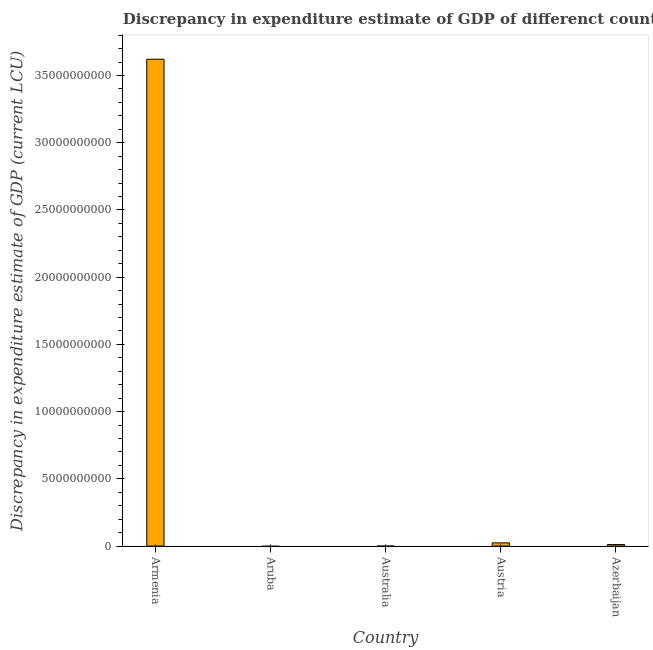Does the graph contain grids?
Provide a short and direct response. No. What is the title of the graph?
Offer a very short reply. Discrepancy in expenditure estimate of GDP of differenct countries in 1998. What is the label or title of the Y-axis?
Your answer should be very brief. Discrepancy in expenditure estimate of GDP (current LCU). What is the discrepancy in expenditure estimate of gdp in Armenia?
Your answer should be very brief. 3.62e+1. Across all countries, what is the maximum discrepancy in expenditure estimate of gdp?
Your response must be concise. 3.62e+1. Across all countries, what is the minimum discrepancy in expenditure estimate of gdp?
Provide a short and direct response. 0. In which country was the discrepancy in expenditure estimate of gdp maximum?
Provide a short and direct response. Armenia. What is the sum of the discrepancy in expenditure estimate of gdp?
Your answer should be compact. 3.66e+1. What is the difference between the discrepancy in expenditure estimate of gdp in Austria and Azerbaijan?
Make the answer very short. 1.25e+08. What is the average discrepancy in expenditure estimate of gdp per country?
Your answer should be compact. 7.31e+09. What is the median discrepancy in expenditure estimate of gdp?
Keep it short and to the point. 1.14e+08. What is the ratio of the discrepancy in expenditure estimate of gdp in Armenia to that in Austria?
Your answer should be very brief. 151.53. Is the discrepancy in expenditure estimate of gdp in Armenia less than that in Azerbaijan?
Keep it short and to the point. No. Is the difference between the discrepancy in expenditure estimate of gdp in Austria and Azerbaijan greater than the difference between any two countries?
Ensure brevity in your answer.  No. What is the difference between the highest and the second highest discrepancy in expenditure estimate of gdp?
Your answer should be compact. 3.60e+1. What is the difference between the highest and the lowest discrepancy in expenditure estimate of gdp?
Provide a succinct answer. 3.62e+1. In how many countries, is the discrepancy in expenditure estimate of gdp greater than the average discrepancy in expenditure estimate of gdp taken over all countries?
Make the answer very short. 1. How many bars are there?
Your response must be concise. 3. Are the values on the major ticks of Y-axis written in scientific E-notation?
Provide a succinct answer. No. What is the Discrepancy in expenditure estimate of GDP (current LCU) of Armenia?
Offer a terse response. 3.62e+1. What is the Discrepancy in expenditure estimate of GDP (current LCU) of Australia?
Provide a succinct answer. 0. What is the Discrepancy in expenditure estimate of GDP (current LCU) of Austria?
Make the answer very short. 2.39e+08. What is the Discrepancy in expenditure estimate of GDP (current LCU) of Azerbaijan?
Ensure brevity in your answer.  1.14e+08. What is the difference between the Discrepancy in expenditure estimate of GDP (current LCU) in Armenia and Austria?
Your answer should be very brief. 3.60e+1. What is the difference between the Discrepancy in expenditure estimate of GDP (current LCU) in Armenia and Azerbaijan?
Give a very brief answer. 3.61e+1. What is the difference between the Discrepancy in expenditure estimate of GDP (current LCU) in Austria and Azerbaijan?
Offer a terse response. 1.25e+08. What is the ratio of the Discrepancy in expenditure estimate of GDP (current LCU) in Armenia to that in Austria?
Keep it short and to the point. 151.53. What is the ratio of the Discrepancy in expenditure estimate of GDP (current LCU) in Armenia to that in Azerbaijan?
Ensure brevity in your answer.  318.92. What is the ratio of the Discrepancy in expenditure estimate of GDP (current LCU) in Austria to that in Azerbaijan?
Keep it short and to the point. 2.1. 